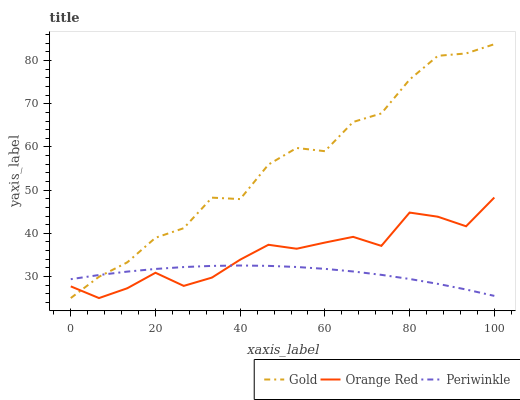Does Periwinkle have the minimum area under the curve?
Answer yes or no. Yes. Does Gold have the maximum area under the curve?
Answer yes or no. Yes. Does Orange Red have the minimum area under the curve?
Answer yes or no. No. Does Orange Red have the maximum area under the curve?
Answer yes or no. No. Is Periwinkle the smoothest?
Answer yes or no. Yes. Is Gold the roughest?
Answer yes or no. Yes. Is Orange Red the smoothest?
Answer yes or no. No. Is Orange Red the roughest?
Answer yes or no. No. Does Orange Red have the lowest value?
Answer yes or no. Yes. Does Gold have the highest value?
Answer yes or no. Yes. Does Orange Red have the highest value?
Answer yes or no. No. Does Periwinkle intersect Gold?
Answer yes or no. Yes. Is Periwinkle less than Gold?
Answer yes or no. No. Is Periwinkle greater than Gold?
Answer yes or no. No. 